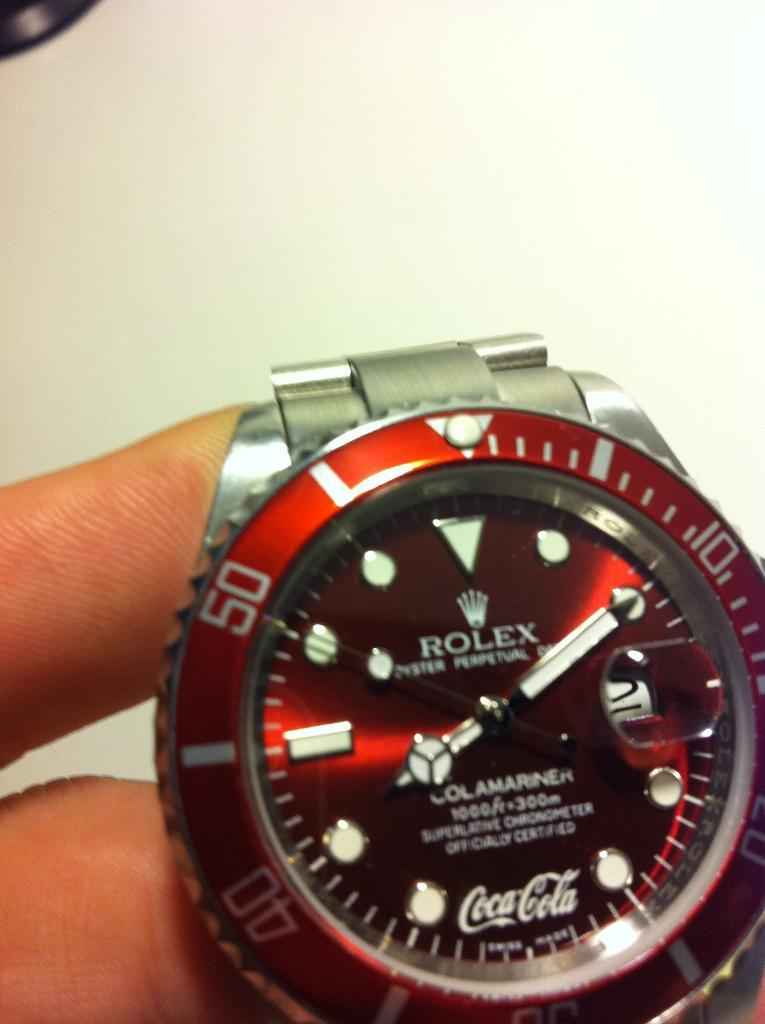What object is being held by a person in the image? There is a watch in the image, and it is being held by a person. What type of earth can be seen in the image? There is no earth visible in the image; it only features a watch being held by a person. 